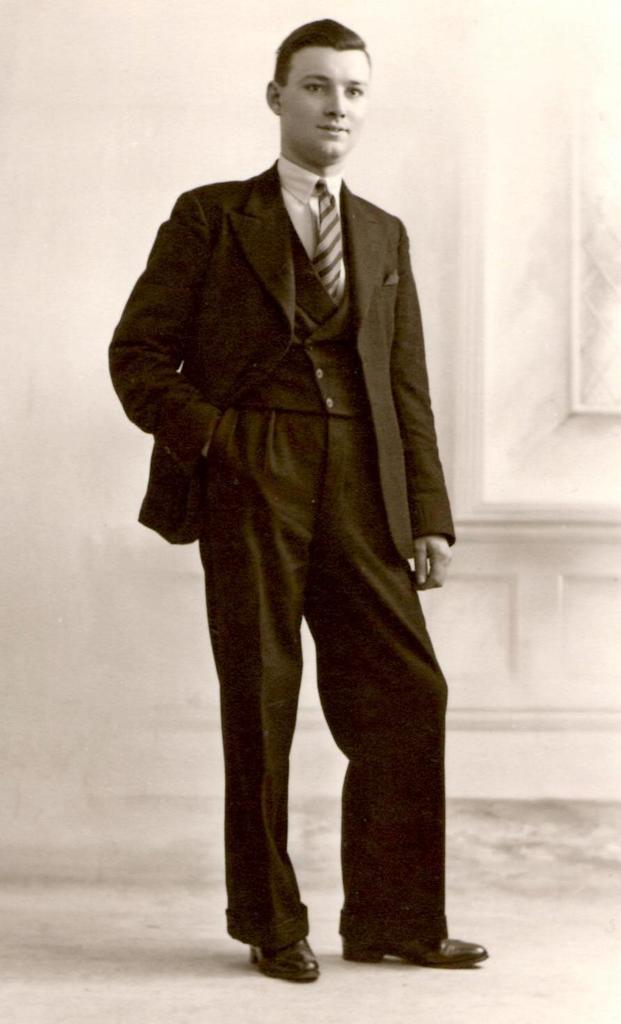Can you describe this image briefly? This is a black and white image. I can see a person standing on the floor. In the background, there is the wall. 